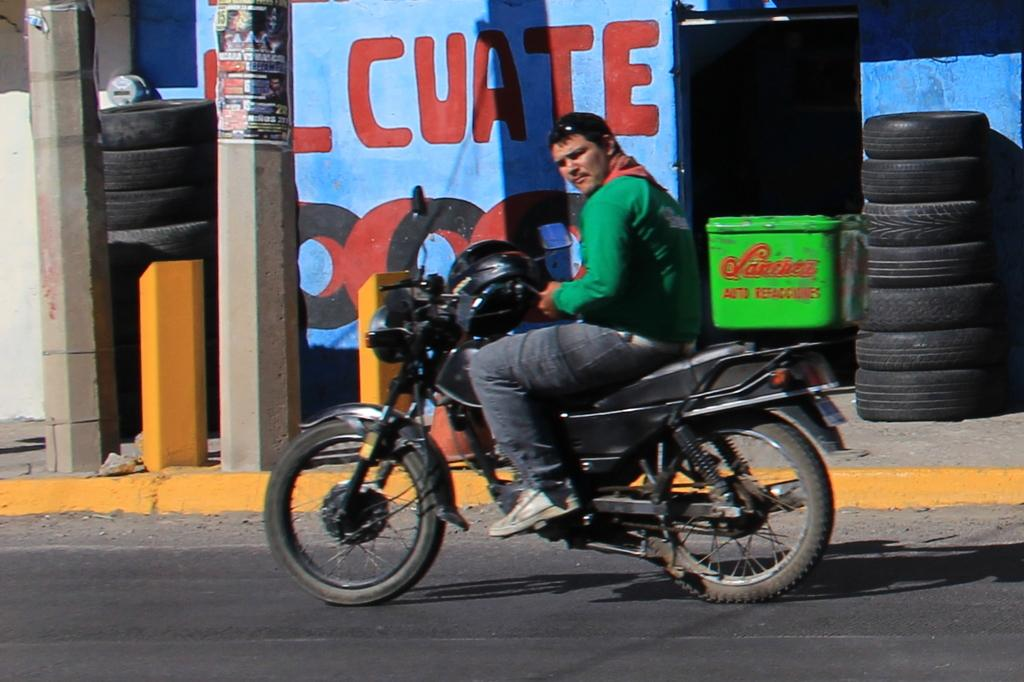What is the person doing in the image? The person is sitting on a motorcycle. Where is the motorcycle located? The motorcycle is on the road. What can be seen in the background of the image? Wheels are visible in the background. What type of agreement is being discussed between the person and the donkey in the image? There is no donkey present in the image, and therefore no agreement is being discussed. 